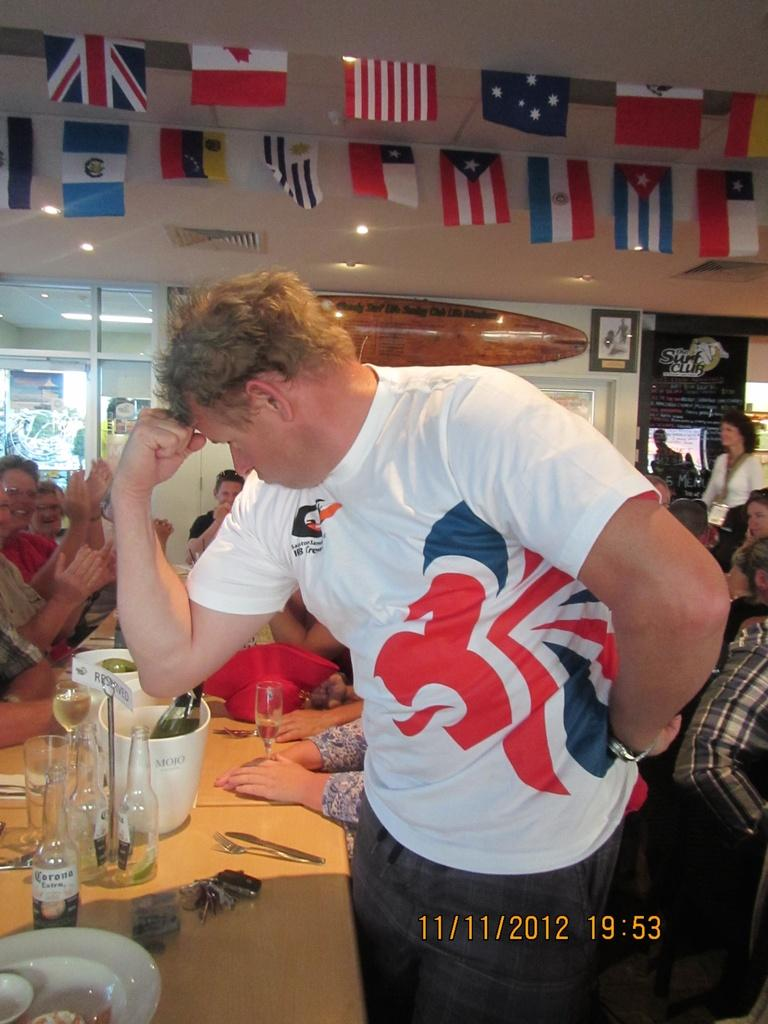<image>
Offer a succinct explanation of the picture presented. A man flexes his right arm in an image dated 11/11/2012. 